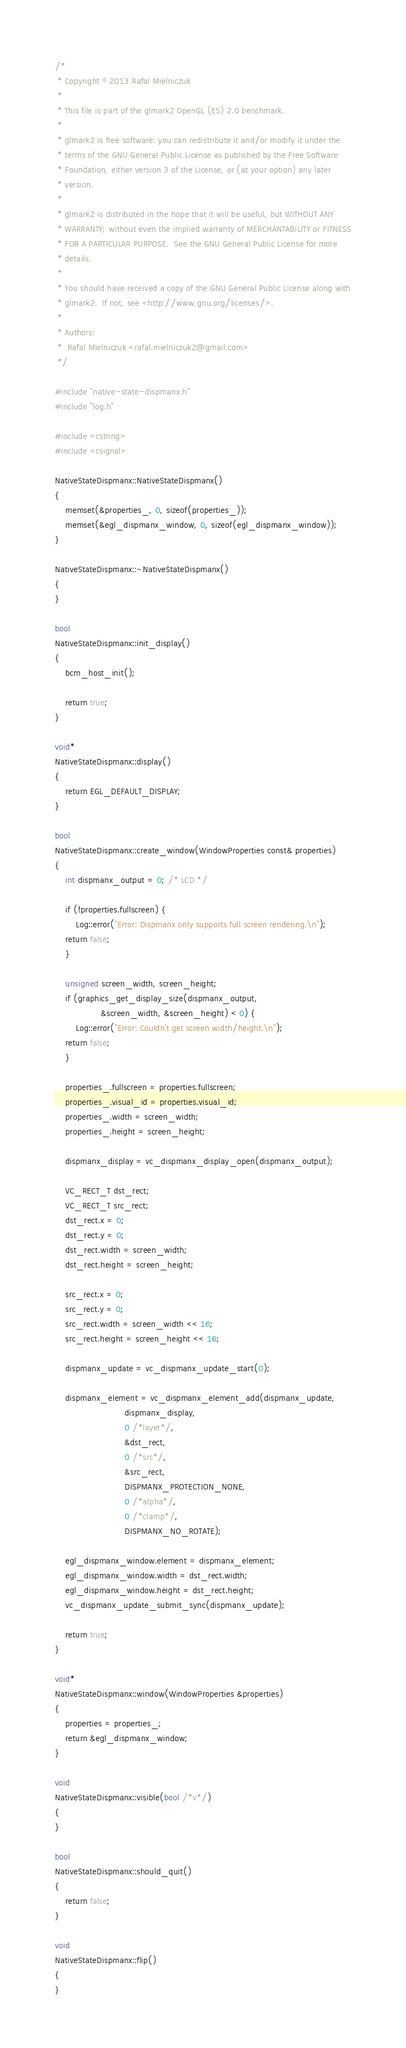Convert code to text. <code><loc_0><loc_0><loc_500><loc_500><_C++_>/*
 * Copyright © 2013 Rafal Mielniczuk
 *
 * This file is part of the glmark2 OpenGL (ES) 2.0 benchmark.
 *
 * glmark2 is free software: you can redistribute it and/or modify it under the
 * terms of the GNU General Public License as published by the Free Software
 * Foundation, either version 3 of the License, or (at your option) any later
 * version.
 *
 * glmark2 is distributed in the hope that it will be useful, but WITHOUT ANY
 * WARRANTY; without even the implied warranty of MERCHANTABILITY or FITNESS
 * FOR A PARTICULAR PURPOSE.  See the GNU General Public License for more
 * details.
 *
 * You should have received a copy of the GNU General Public License along with
 * glmark2.  If not, see <http://www.gnu.org/licenses/>.
 *
 * Authors:
 *  Rafal Mielniczuk <rafal.mielniczuk2@gmail.com>
 */

#include "native-state-dispmanx.h"
#include "log.h"

#include <cstring>
#include <csignal>

NativeStateDispmanx::NativeStateDispmanx()
{
    memset(&properties_, 0, sizeof(properties_));
    memset(&egl_dispmanx_window, 0, sizeof(egl_dispmanx_window));
}

NativeStateDispmanx::~NativeStateDispmanx()
{
}

bool
NativeStateDispmanx::init_display()
{
    bcm_host_init();

    return true;
}

void*
NativeStateDispmanx::display()
{
    return EGL_DEFAULT_DISPLAY;
}

bool
NativeStateDispmanx::create_window(WindowProperties const& properties)
{
    int dispmanx_output = 0; /* LCD */

    if (!properties.fullscreen) {
        Log::error("Error: Dispmanx only supports full screen rendering.\n");
	return false;
    }

    unsigned screen_width, screen_height;
    if (graphics_get_display_size(dispmanx_output,
				  &screen_width, &screen_height) < 0) {
        Log::error("Error: Couldn't get screen width/height.\n");
	return false;
    }

    properties_.fullscreen = properties.fullscreen;
    properties_.visual_id = properties.visual_id;
    properties_.width = screen_width;
    properties_.height = screen_height;

    dispmanx_display = vc_dispmanx_display_open(dispmanx_output);

    VC_RECT_T dst_rect;
    VC_RECT_T src_rect;
    dst_rect.x = 0;
    dst_rect.y = 0;
    dst_rect.width = screen_width;
    dst_rect.height = screen_height;

    src_rect.x = 0;
    src_rect.y = 0;
    src_rect.width = screen_width << 16;
    src_rect.height = screen_height << 16;

    dispmanx_update = vc_dispmanx_update_start(0);

    dispmanx_element = vc_dispmanx_element_add(dispmanx_update,
					       dispmanx_display,
					       0 /*layer*/,
					       &dst_rect,
					       0 /*src*/,
					       &src_rect,
					       DISPMANX_PROTECTION_NONE,
					       0 /*alpha*/,
					       0 /*clamp*/,
					       DISPMANX_NO_ROTATE);

    egl_dispmanx_window.element = dispmanx_element;
    egl_dispmanx_window.width = dst_rect.width;
    egl_dispmanx_window.height = dst_rect.height;
    vc_dispmanx_update_submit_sync(dispmanx_update);

    return true;
}

void*
NativeStateDispmanx::window(WindowProperties &properties)
{
    properties = properties_;
    return &egl_dispmanx_window;
}

void
NativeStateDispmanx::visible(bool /*v*/)
{
}

bool
NativeStateDispmanx::should_quit()
{
    return false;
}

void
NativeStateDispmanx::flip()
{
}

</code> 